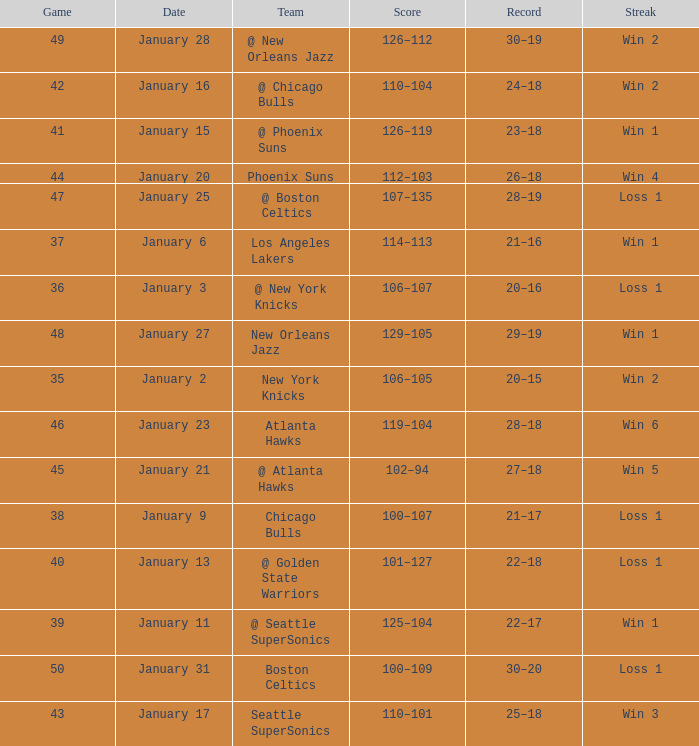What Game had a Score of 129–105? 48.0. 